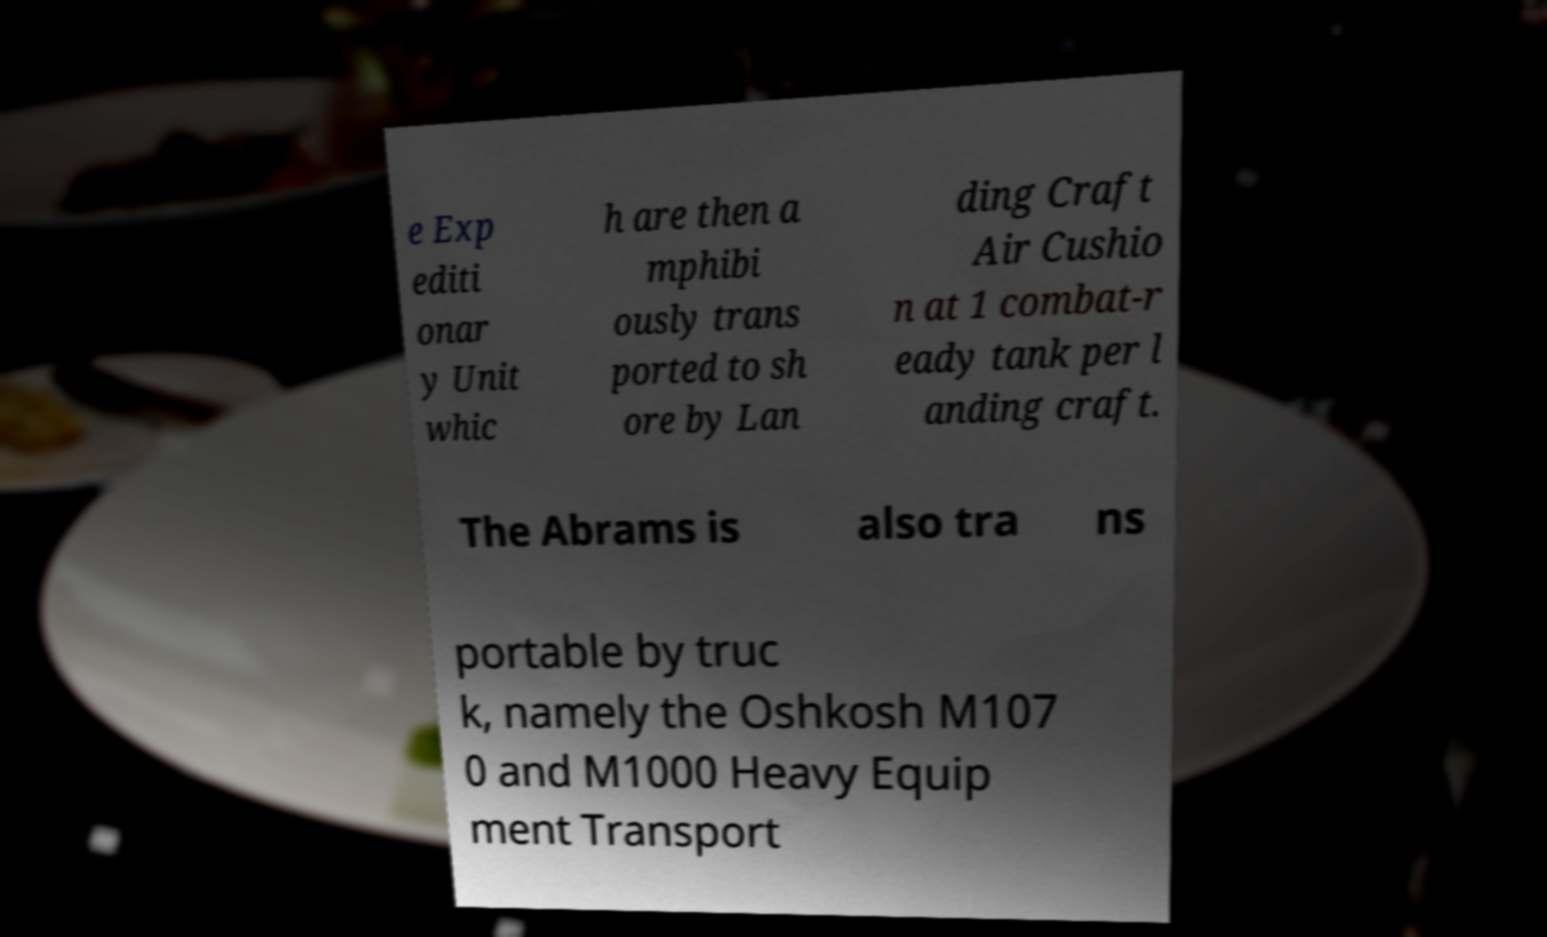Please read and relay the text visible in this image. What does it say? e Exp editi onar y Unit whic h are then a mphibi ously trans ported to sh ore by Lan ding Craft Air Cushio n at 1 combat-r eady tank per l anding craft. The Abrams is also tra ns portable by truc k, namely the Oshkosh M107 0 and M1000 Heavy Equip ment Transport 